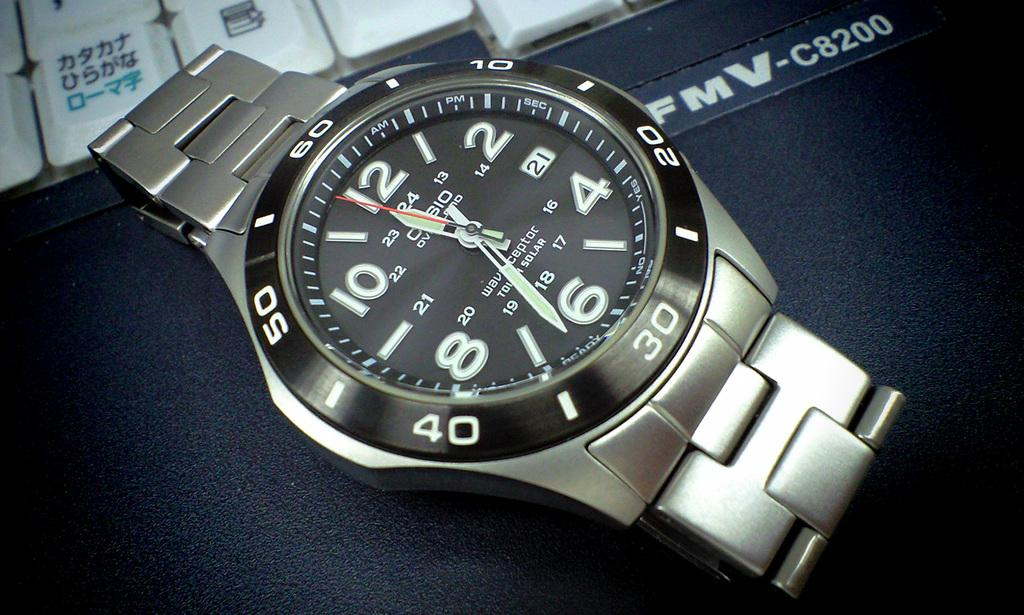<image>
Provide a brief description of the given image. A silver watch with the hands on the face at 11:33. 